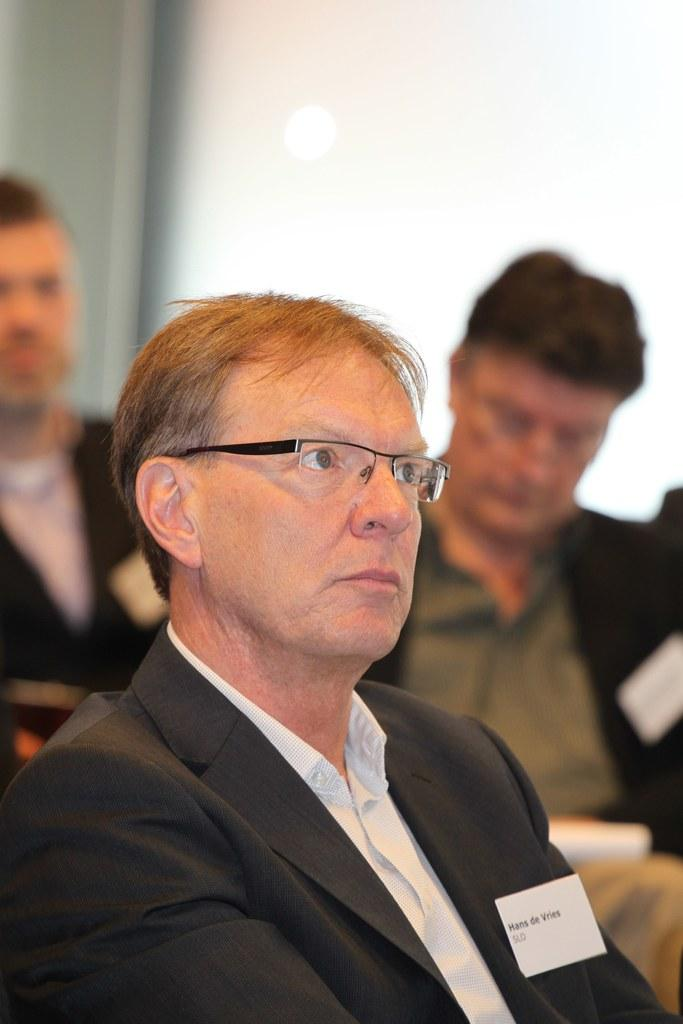What are the people in the image doing? The people in the image are sitting on chairs. Can you describe the background of the image? The background of the image is blurred. What type of shop can be seen in the background of the image? There is no shop visible in the background of the image; the background is blurred. What discovery was made by the people sitting on the chairs in the image? There is no indication of a discovery being made in the image; the people are simply sitting on chairs. 